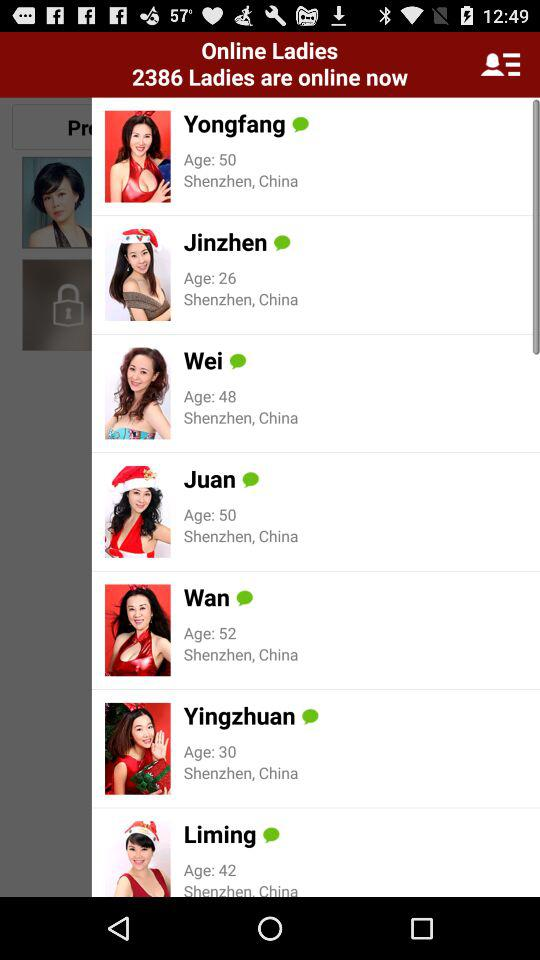What is the age of Wan? The age of Wan is 52. 